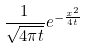<formula> <loc_0><loc_0><loc_500><loc_500>\frac { 1 } { \sqrt { 4 \pi t } } e ^ { - \frac { x ^ { 2 } } { 4 t } }</formula> 